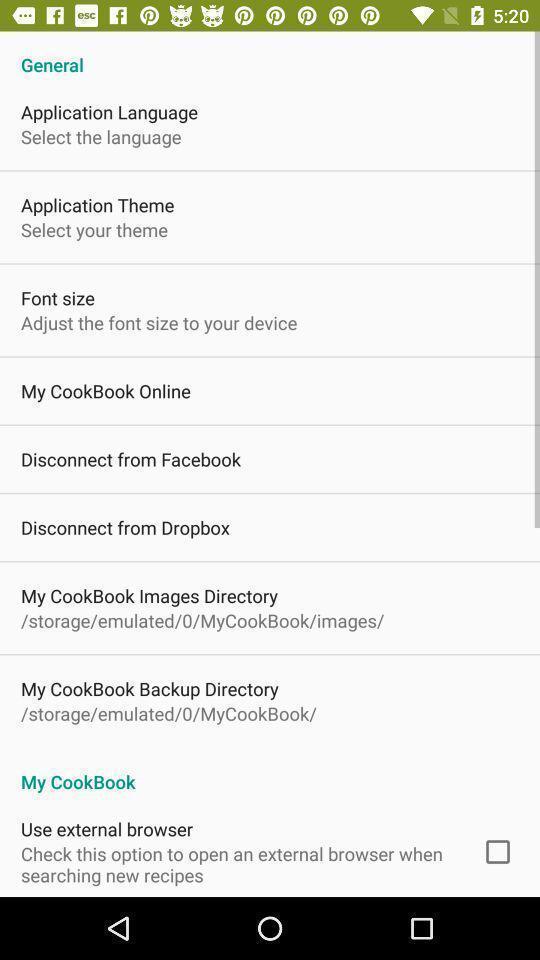Describe the key features of this screenshot. Page displaying various information in food application. 